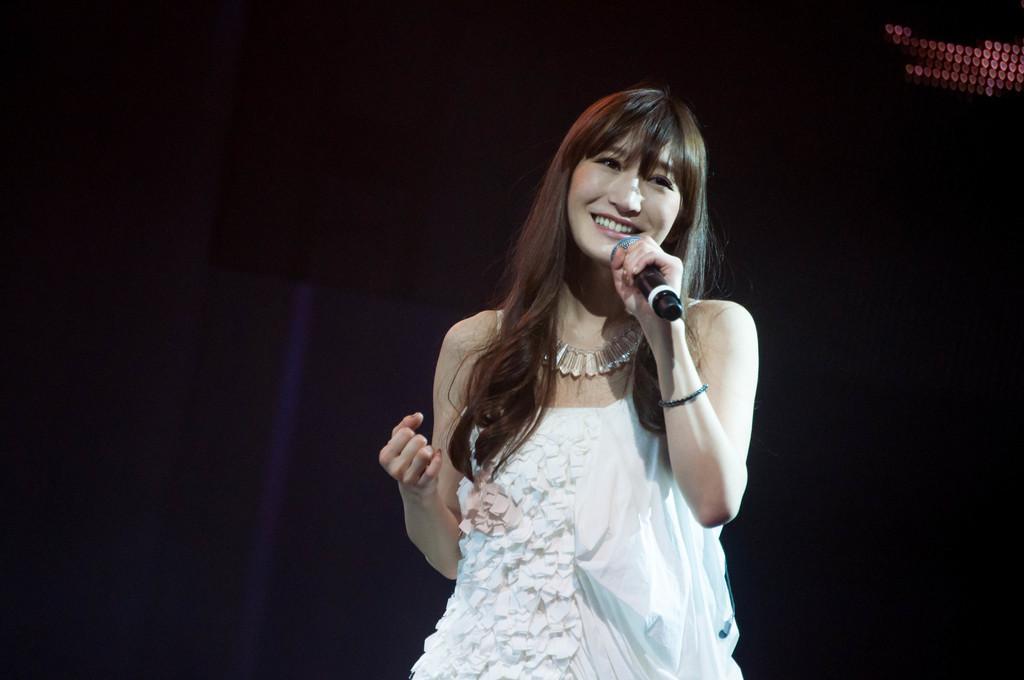How would you summarize this image in a sentence or two? There a pretty lady in the image. She is wearing a white dress and a beautiful necklace. She is holding a microphone in her left hand. She is smiling. In the background there is a curtain and lights at the top right corner.  